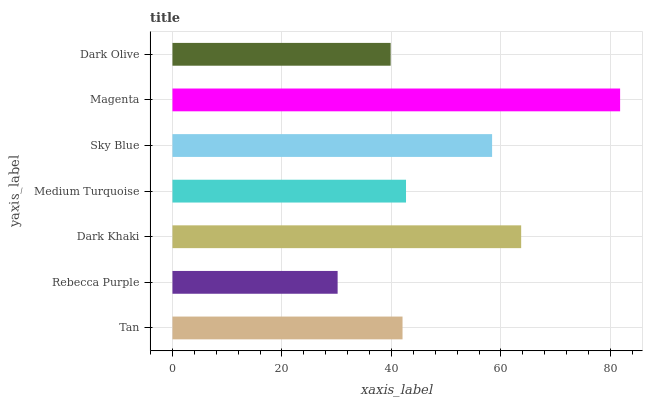Is Rebecca Purple the minimum?
Answer yes or no. Yes. Is Magenta the maximum?
Answer yes or no. Yes. Is Dark Khaki the minimum?
Answer yes or no. No. Is Dark Khaki the maximum?
Answer yes or no. No. Is Dark Khaki greater than Rebecca Purple?
Answer yes or no. Yes. Is Rebecca Purple less than Dark Khaki?
Answer yes or no. Yes. Is Rebecca Purple greater than Dark Khaki?
Answer yes or no. No. Is Dark Khaki less than Rebecca Purple?
Answer yes or no. No. Is Medium Turquoise the high median?
Answer yes or no. Yes. Is Medium Turquoise the low median?
Answer yes or no. Yes. Is Dark Olive the high median?
Answer yes or no. No. Is Rebecca Purple the low median?
Answer yes or no. No. 